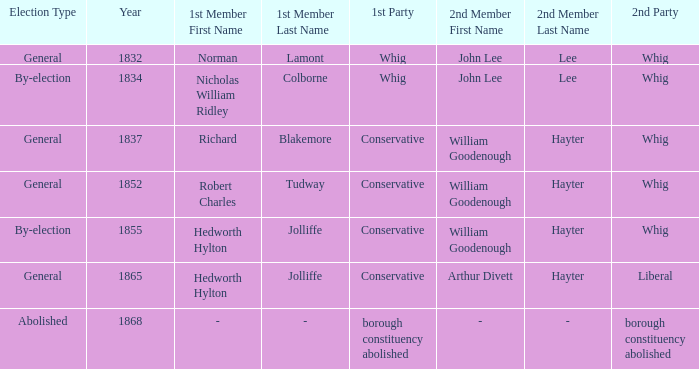Which electoral event features richard blakemore as the primary member and william goodenough hayter as the secondary member? 1837.0. 